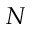<formula> <loc_0><loc_0><loc_500><loc_500>N</formula> 